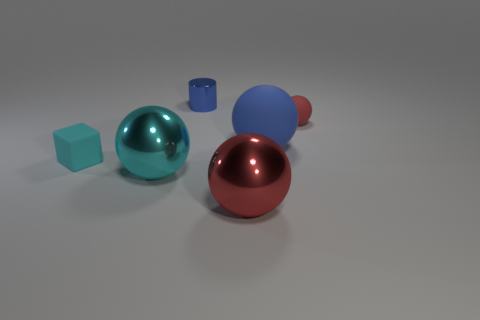Is the number of gray cylinders greater than the number of rubber spheres?
Your response must be concise. No. What is the material of the big red object?
Provide a succinct answer. Metal. What number of other things are there of the same material as the large red object
Offer a terse response. 2. How many green rubber balls are there?
Provide a succinct answer. 0. What material is the large cyan object that is the same shape as the big red object?
Keep it short and to the point. Metal. Is the blue thing that is in front of the tiny blue metallic cylinder made of the same material as the tiny blue cylinder?
Your response must be concise. No. Are there more large shiny things that are on the right side of the tiny shiny object than large rubber things that are behind the big matte ball?
Offer a very short reply. Yes. The cyan sphere has what size?
Make the answer very short. Large. The other small thing that is the same material as the small red thing is what shape?
Ensure brevity in your answer.  Cube. There is a red object left of the tiny matte ball; is its shape the same as the blue matte thing?
Keep it short and to the point. Yes. 